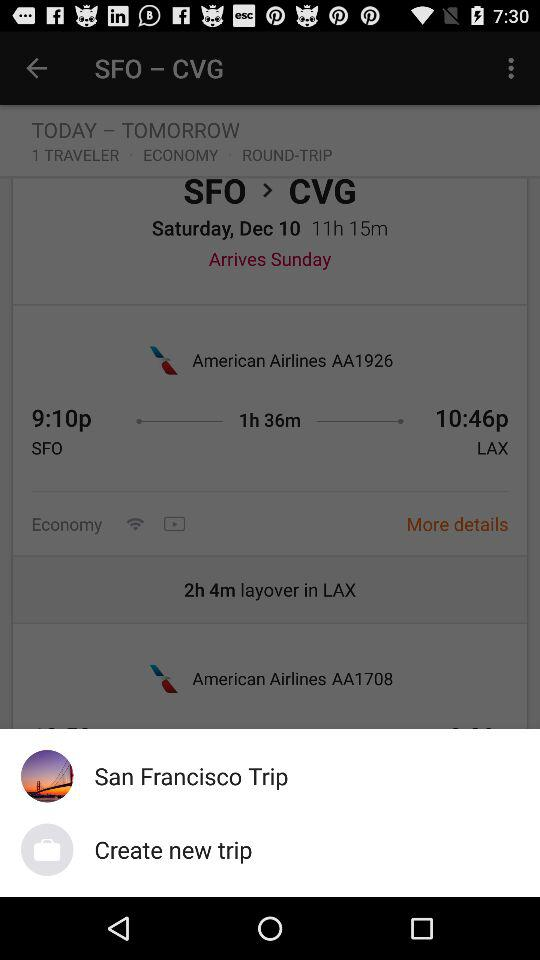How long is the layover in LAX?
Answer the question using a single word or phrase. 2h 4m 